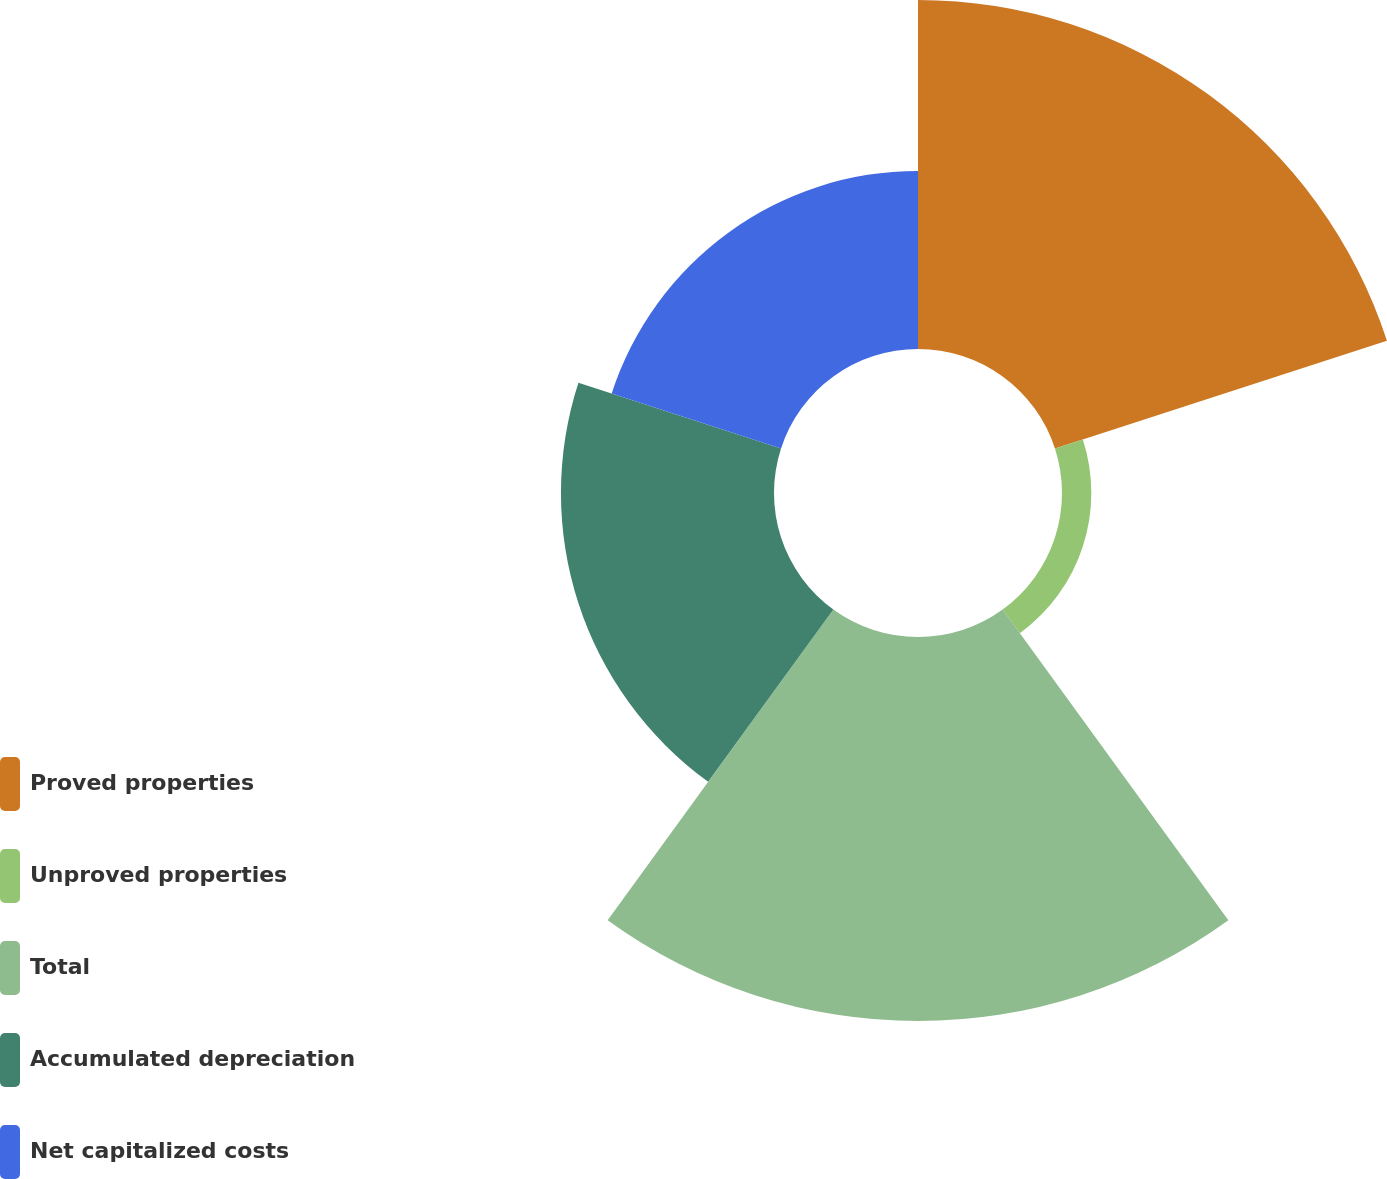Convert chart. <chart><loc_0><loc_0><loc_500><loc_500><pie_chart><fcel>Proved properties<fcel>Unproved properties<fcel>Total<fcel>Accumulated depreciation<fcel>Net capitalized costs<nl><fcel>30.26%<fcel>2.54%<fcel>33.29%<fcel>18.47%<fcel>15.44%<nl></chart> 